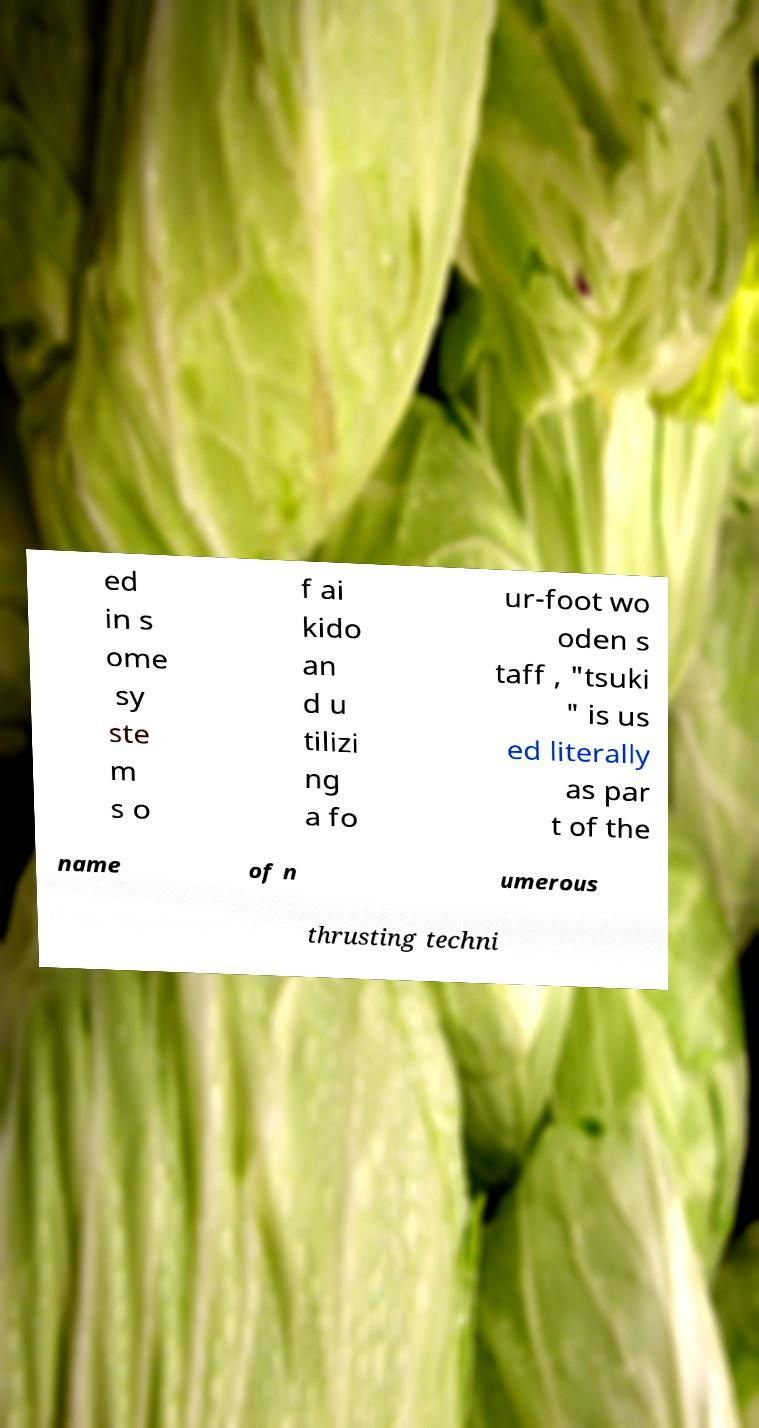For documentation purposes, I need the text within this image transcribed. Could you provide that? ed in s ome sy ste m s o f ai kido an d u tilizi ng a fo ur-foot wo oden s taff , "tsuki " is us ed literally as par t of the name of n umerous thrusting techni 